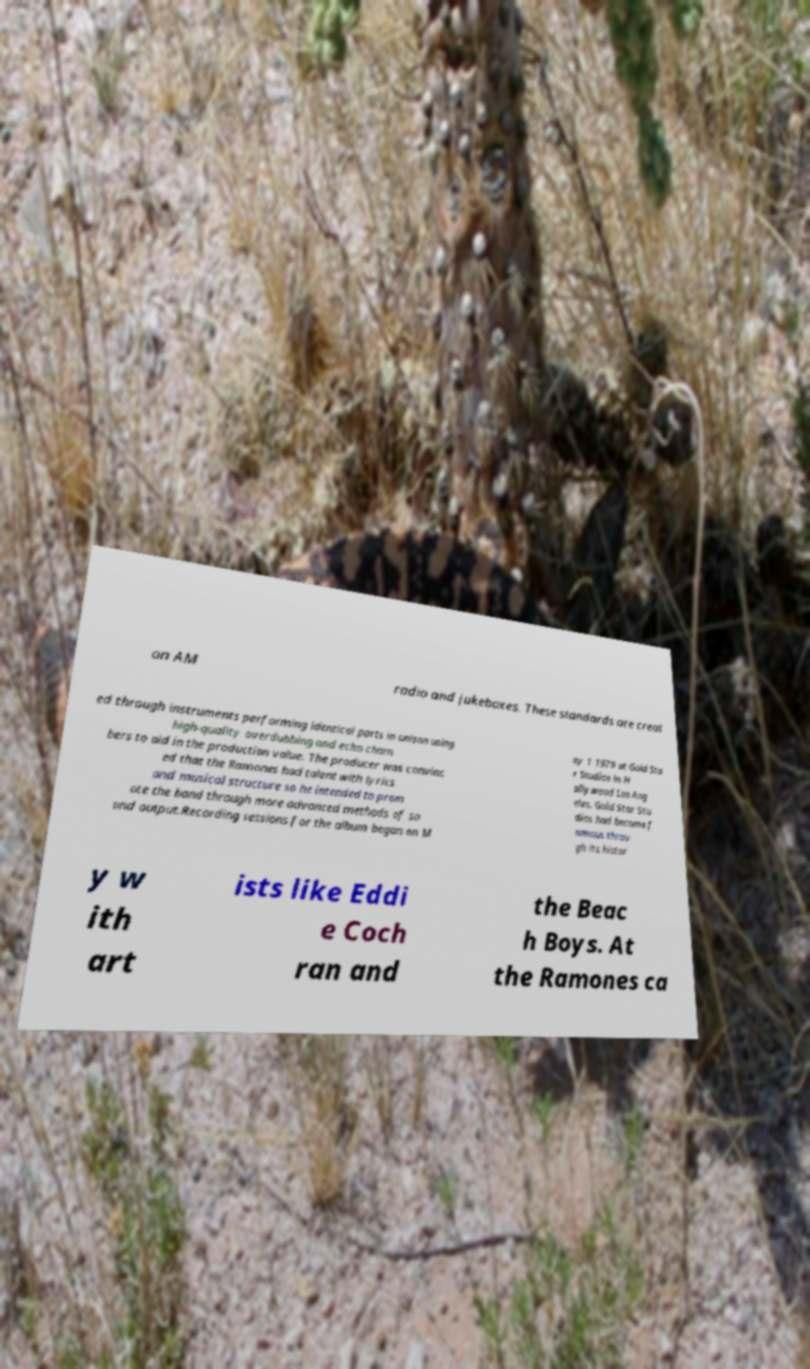Please identify and transcribe the text found in this image. on AM radio and jukeboxes. These standards are creat ed through instruments performing identical parts in unison using high-quality overdubbing and echo cham bers to aid in the production value. The producer was convinc ed that the Ramones had talent with lyrics and musical structure so he intended to prom ote the band through more advanced methods of so und output.Recording sessions for the album began on M ay 1 1979 at Gold Sta r Studios in H ollywood Los Ang eles. Gold Star Stu dios had become f amous throu gh its histor y w ith art ists like Eddi e Coch ran and the Beac h Boys. At the Ramones ca 